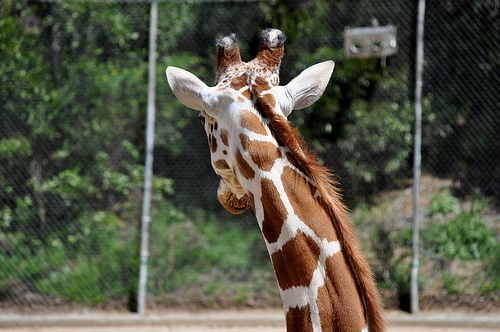<image>
Can you confirm if the spot is on the neck? Yes. Looking at the image, I can see the spot is positioned on top of the neck, with the neck providing support. 